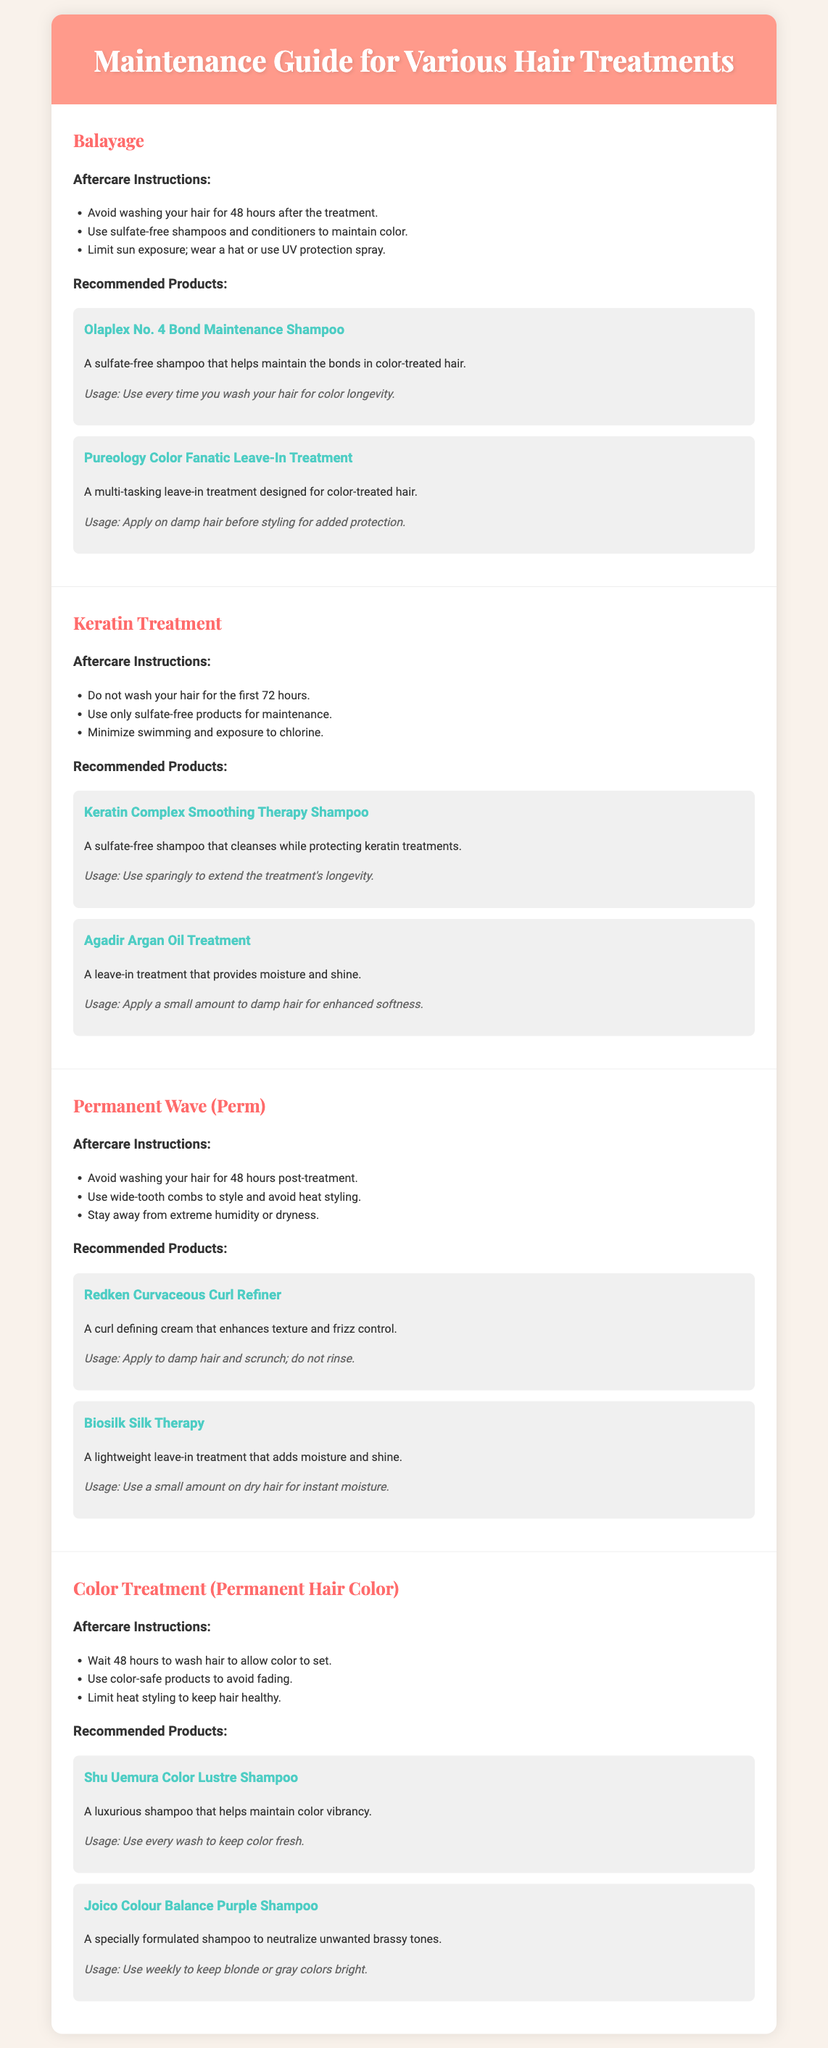what should you avoid directly after a balayage treatment? The document notes to avoid washing your hair for 48 hours after the balayage treatment.
Answer: washing your hair for 48 hours how long should you wait to wash hair after a color treatment? The instructions state to wait 48 hours to wash hair to allow color to set after a color treatment.
Answer: 48 hours what type of shampoo is recommended for keratin treatments? The recommended shampoo for keratin treatments is sulfate-free.
Answer: sulfate-free which product is suggested for enhancing texture in a perm? The document suggests using Redken Curvaceous Curl Refiner for enhancing texture in a perm.
Answer: Redken Curvaceous Curl Refiner how often should you use Joico Colour Balance Purple Shampoo? The document states to use Joico Colour Balance Purple Shampoo weekly to maintain vibrancy.
Answer: weekly what is a recommended leave-in treatment for color-treated hair? Pureology Color Fanatic Leave-In Treatment is suggested for color-treated hair maintenance.
Answer: Pureology Color Fanatic Leave-In Treatment what product helps to maintain vibrant color? The document lists Shu Uemura Color Lustre Shampoo as a product that helps maintain color vibrancy.
Answer: Shu Uemura Color Lustre Shampoo what should you limit to keep hair healthy after color treatment? The aftercare instructions recommend limiting heat styling to keep hair healthy after a color treatment.
Answer: heat styling for keratin treatment aftercare, what activity should be minimized? The document advises minimizing swimming and exposure to chlorine as part of the keratin treatment aftercare.
Answer: swimming and exposure to chlorine 